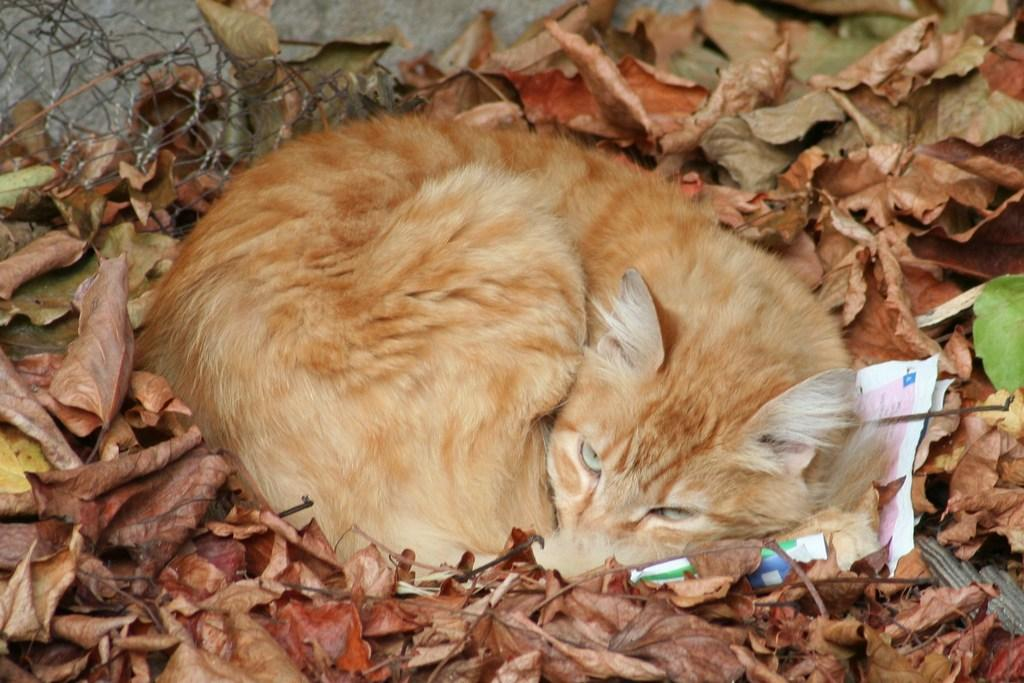What type of animal is present in the image? There is a cat in the image. What is the cat doing in the image? The cat is sleeping. What can be seen around the cat? There are leaves around the cat. What is located behind the cat? There is a fence behind the cat. What type of harbor can be seen in the image? There is no harbor present in the image; it features a cat sleeping among leaves with a fence in the background. 